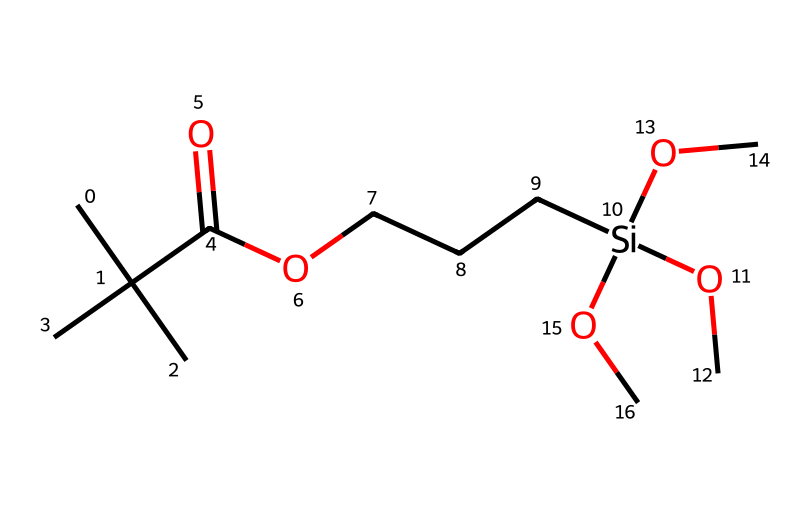How many carbon atoms are in this silane-modified acrylic binder? By examining the SMILES representation, we can identify each segment that denotes a carbon atom. The notation "CC(C)(C)" indicates there are three carbon atoms in a branched structure, and "C(=O)O" suggests one additional carbon is present. Counting other individual "C" directly reveals there are five more in "CCC" and forms attached to the silicon. In total, there are eight carbon atoms.
Answer: eight What functional group is indicated by "C(=O)O" in the structure? The part "C(=O)O" represents a carboxylic acid functional group. The "=" indicates a double bond between carbon and oxygen, while the "O" signifies a hydroxyl group (-OH) attached to the carbon. Thus, "C(=O)O" features the characteristics of a carboxyl group.
Answer: carboxylic acid What type of molecules does the presence of silicon suggest this compound is related to? The presence of silicon in this structure denotes that this compound is related to silanes. Silanes consist of silicon atoms bonded with carbon or hydrogen and are typically utilized in various chemical applications, including binders in paints.
Answer: silanes How many ethoxy groups are present in this chemical? The notation "OC" appears three times within the structure, indicating three ethoxy groups (each consisting of an "O" bonded to an "C"). Therefore, the total count is three based on this observation.
Answer: three Is this silane-modified acrylic binder likely to have good adhesion properties? Yes. Silane-modified acrylics generally enhance adhesion due to the silane functional groups that bond well with both organic and inorganic surfaces. This structure's combination of acrylic and silane characteristics is typical for improving adhesion in coating applications like miniature paints.
Answer: yes What is the main purpose of including a silane in acrylic binders? Including silanes in acrylic binders serves to promote adhesion and improve water resistance, which can help enhance the performance of paints in various applications, particularly in miniature painting where durability and finish are crucial.
Answer: adhesion 